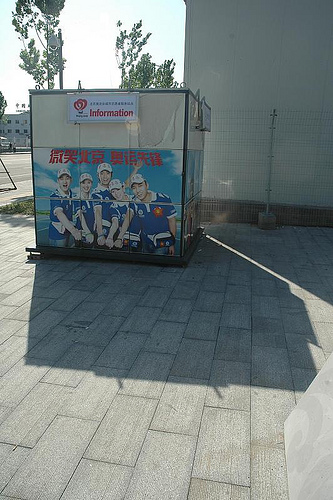<image>
Can you confirm if the metal fence is on the concrete floor? Yes. Looking at the image, I can see the metal fence is positioned on top of the concrete floor, with the concrete floor providing support. 